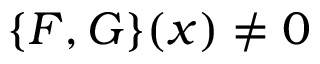<formula> <loc_0><loc_0><loc_500><loc_500>\{ F , G \} ( x ) \neq 0</formula> 